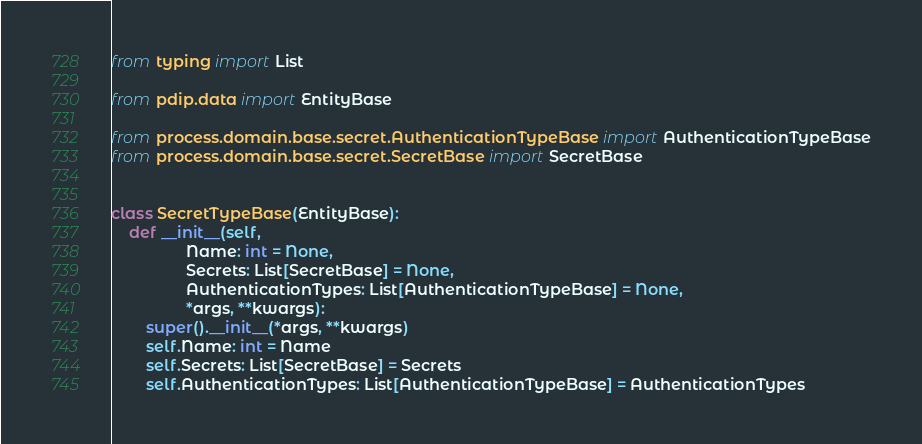Convert code to text. <code><loc_0><loc_0><loc_500><loc_500><_Python_>from typing import List

from pdip.data import EntityBase

from process.domain.base.secret.AuthenticationTypeBase import AuthenticationTypeBase
from process.domain.base.secret.SecretBase import SecretBase


class SecretTypeBase(EntityBase):
    def __init__(self,
                 Name: int = None,
                 Secrets: List[SecretBase] = None,
                 AuthenticationTypes: List[AuthenticationTypeBase] = None,
                 *args, **kwargs):
        super().__init__(*args, **kwargs)
        self.Name: int = Name
        self.Secrets: List[SecretBase] = Secrets
        self.AuthenticationTypes: List[AuthenticationTypeBase] = AuthenticationTypes
</code> 